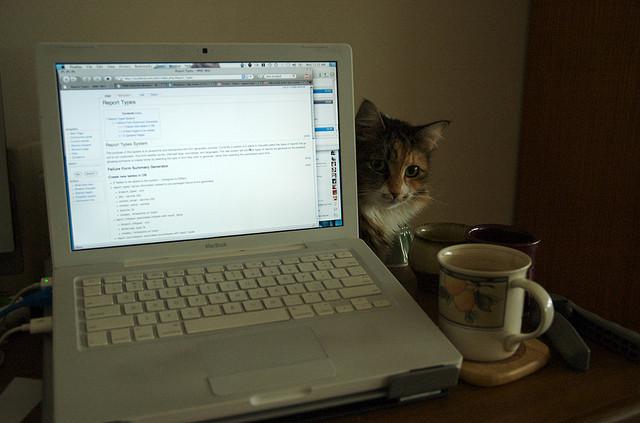What kind of cat is in the photo?
Give a very brief answer. Calico. What color is the cat's eyes?
Keep it brief. Green. What color is the cat's head?
Write a very short answer. Brown. Are there 2 laptops here?
Answer briefly. No. What is the cup made out of?
Keep it brief. Ceramic. What kind of animal is sitting near the monitor?
Answer briefly. Cat. What are they drinking?
Answer briefly. Coffee. What color is this keyboard?
Quick response, please. White. What is the cat's mouth open?
Quick response, please. Not possible. How many keys are seen from the keyboard?
Quick response, please. All. Is the persons hair long or short?
Short answer required. Short. What does the screen say?
Quick response, please. Report types. Is there a cat on the coffee?
Keep it brief. No. What electronic device is this?
Answer briefly. Laptop. Is there a flower on the screen?
Concise answer only. No. What color is the screen?
Concise answer only. White. Is this a laptop computer?
Quick response, please. Yes. What animal is in the picture?
Answer briefly. Cat. What kind of law is the book?
Short answer required. No. What brand computer?
Be succinct. Apple. Which mainframe is being shown on the laptop?
Short answer required. Windows. What is to the right of the laptop?
Give a very brief answer. Cat. What is she drinking?
Quick response, please. Coffee. Where are these laptops?
Be succinct. Desk. Is that a kitten?
Quick response, please. Yes. What colors are the laptops?
Quick response, please. White. How many keyboards can be seen?
Concise answer only. 1. How many screens are being used?
Keep it brief. 1. Will that cat catch mice?
Answer briefly. Yes. What color is the mug?
Quick response, please. White. Is this cluttered or organized?
Concise answer only. Cluttered. Is there a bonsai in the background?
Quick response, please. No. What is the cat doing?
Give a very brief answer. Laying down. Are these mac laptops?
Concise answer only. Yes. Is that a ceramic cup?
Write a very short answer. Yes. How many monitors are in the image?
Answer briefly. 1. Is this a keyboard for a laptop?
Be succinct. Yes. How many computers are there?
Give a very brief answer. 1. Does this cat like computers?
Answer briefly. Yes. What is the person drinking?
Give a very brief answer. Coffee. What color is the laptop?
Short answer required. White. What kind of animal is in the picture?
Keep it brief. Cat. How many electronic devices are there?
Short answer required. 1. What general operating system is the computer running?
Be succinct. Windows. What color is the cat's mittens?
Concise answer only. White. Is the drink on this desk open?
Concise answer only. Yes. Is there a mouse in view?
Keep it brief. No. What is the laptop brand?
Keep it brief. Apple. How many computers are on the desk?
Write a very short answer. 1. Is there a desktop computer included in this photo?
Concise answer only. No. Is that cup from Hardee's?
Write a very short answer. No. How many keyboards are visible?
Write a very short answer. 1. How many cats are on the keyboard?
Write a very short answer. 0. How many laptops are on the table?
Answer briefly. 1. Is the computer on its screen saver?
Give a very brief answer. No. What is the predominant color in this photo?
Keep it brief. White. Is this a Dell laptop?
Keep it brief. No. How many cups?
Keep it brief. 3. What color is the light from the laptop?
Concise answer only. White. What color is the keyboard?
Give a very brief answer. White. What is the cat laying on?
Be succinct. Table. How many mugs are on the table?
Concise answer only. 3. Is the computer a Mac?
Quick response, please. Yes. Is the cat on the left real?
Keep it brief. Yes. Is there a TV in room?
Write a very short answer. No. Is there a mouse?
Give a very brief answer. No. How many pens in the cup?
Be succinct. 0. Is the cat looking up?
Write a very short answer. No. What beverage is in the cup?
Quick response, please. Coffee. Does the laptop appear to have a crack in the screen?
Keep it brief. No. 